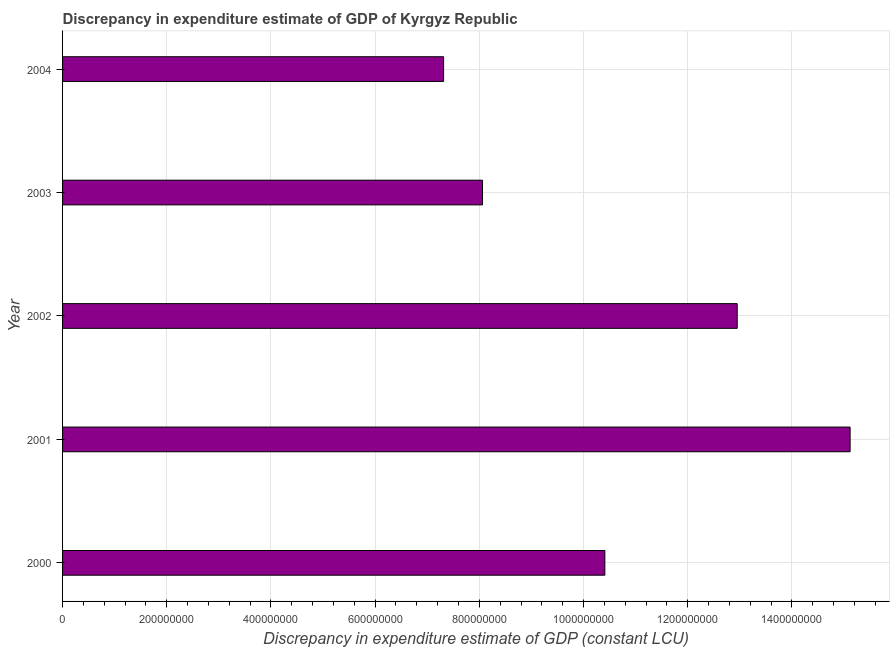Does the graph contain any zero values?
Your answer should be compact. No. What is the title of the graph?
Your answer should be compact. Discrepancy in expenditure estimate of GDP of Kyrgyz Republic. What is the label or title of the X-axis?
Ensure brevity in your answer.  Discrepancy in expenditure estimate of GDP (constant LCU). What is the discrepancy in expenditure estimate of gdp in 2002?
Your answer should be compact. 1.29e+09. Across all years, what is the maximum discrepancy in expenditure estimate of gdp?
Ensure brevity in your answer.  1.51e+09. Across all years, what is the minimum discrepancy in expenditure estimate of gdp?
Offer a terse response. 7.31e+08. What is the sum of the discrepancy in expenditure estimate of gdp?
Provide a succinct answer. 5.39e+09. What is the difference between the discrepancy in expenditure estimate of gdp in 2003 and 2004?
Keep it short and to the point. 7.47e+07. What is the average discrepancy in expenditure estimate of gdp per year?
Offer a terse response. 1.08e+09. What is the median discrepancy in expenditure estimate of gdp?
Provide a succinct answer. 1.04e+09. Do a majority of the years between 2002 and 2000 (inclusive) have discrepancy in expenditure estimate of gdp greater than 840000000 LCU?
Make the answer very short. Yes. What is the ratio of the discrepancy in expenditure estimate of gdp in 2003 to that in 2004?
Offer a very short reply. 1.1. Is the difference between the discrepancy in expenditure estimate of gdp in 2003 and 2004 greater than the difference between any two years?
Ensure brevity in your answer.  No. What is the difference between the highest and the second highest discrepancy in expenditure estimate of gdp?
Your response must be concise. 2.17e+08. What is the difference between the highest and the lowest discrepancy in expenditure estimate of gdp?
Provide a succinct answer. 7.80e+08. Are all the bars in the graph horizontal?
Provide a succinct answer. Yes. How many years are there in the graph?
Offer a very short reply. 5. What is the difference between two consecutive major ticks on the X-axis?
Your answer should be compact. 2.00e+08. What is the Discrepancy in expenditure estimate of GDP (constant LCU) of 2000?
Give a very brief answer. 1.04e+09. What is the Discrepancy in expenditure estimate of GDP (constant LCU) in 2001?
Offer a terse response. 1.51e+09. What is the Discrepancy in expenditure estimate of GDP (constant LCU) in 2002?
Ensure brevity in your answer.  1.29e+09. What is the Discrepancy in expenditure estimate of GDP (constant LCU) in 2003?
Ensure brevity in your answer.  8.06e+08. What is the Discrepancy in expenditure estimate of GDP (constant LCU) of 2004?
Ensure brevity in your answer.  7.31e+08. What is the difference between the Discrepancy in expenditure estimate of GDP (constant LCU) in 2000 and 2001?
Provide a succinct answer. -4.71e+08. What is the difference between the Discrepancy in expenditure estimate of GDP (constant LCU) in 2000 and 2002?
Your answer should be compact. -2.54e+08. What is the difference between the Discrepancy in expenditure estimate of GDP (constant LCU) in 2000 and 2003?
Your response must be concise. 2.35e+08. What is the difference between the Discrepancy in expenditure estimate of GDP (constant LCU) in 2000 and 2004?
Give a very brief answer. 3.09e+08. What is the difference between the Discrepancy in expenditure estimate of GDP (constant LCU) in 2001 and 2002?
Provide a succinct answer. 2.17e+08. What is the difference between the Discrepancy in expenditure estimate of GDP (constant LCU) in 2001 and 2003?
Ensure brevity in your answer.  7.06e+08. What is the difference between the Discrepancy in expenditure estimate of GDP (constant LCU) in 2001 and 2004?
Your answer should be compact. 7.80e+08. What is the difference between the Discrepancy in expenditure estimate of GDP (constant LCU) in 2002 and 2003?
Provide a succinct answer. 4.89e+08. What is the difference between the Discrepancy in expenditure estimate of GDP (constant LCU) in 2002 and 2004?
Your answer should be very brief. 5.64e+08. What is the difference between the Discrepancy in expenditure estimate of GDP (constant LCU) in 2003 and 2004?
Provide a succinct answer. 7.47e+07. What is the ratio of the Discrepancy in expenditure estimate of GDP (constant LCU) in 2000 to that in 2001?
Make the answer very short. 0.69. What is the ratio of the Discrepancy in expenditure estimate of GDP (constant LCU) in 2000 to that in 2002?
Your answer should be very brief. 0.8. What is the ratio of the Discrepancy in expenditure estimate of GDP (constant LCU) in 2000 to that in 2003?
Ensure brevity in your answer.  1.29. What is the ratio of the Discrepancy in expenditure estimate of GDP (constant LCU) in 2000 to that in 2004?
Provide a short and direct response. 1.42. What is the ratio of the Discrepancy in expenditure estimate of GDP (constant LCU) in 2001 to that in 2002?
Make the answer very short. 1.17. What is the ratio of the Discrepancy in expenditure estimate of GDP (constant LCU) in 2001 to that in 2003?
Give a very brief answer. 1.88. What is the ratio of the Discrepancy in expenditure estimate of GDP (constant LCU) in 2001 to that in 2004?
Make the answer very short. 2.07. What is the ratio of the Discrepancy in expenditure estimate of GDP (constant LCU) in 2002 to that in 2003?
Offer a very short reply. 1.61. What is the ratio of the Discrepancy in expenditure estimate of GDP (constant LCU) in 2002 to that in 2004?
Your response must be concise. 1.77. What is the ratio of the Discrepancy in expenditure estimate of GDP (constant LCU) in 2003 to that in 2004?
Your response must be concise. 1.1. 